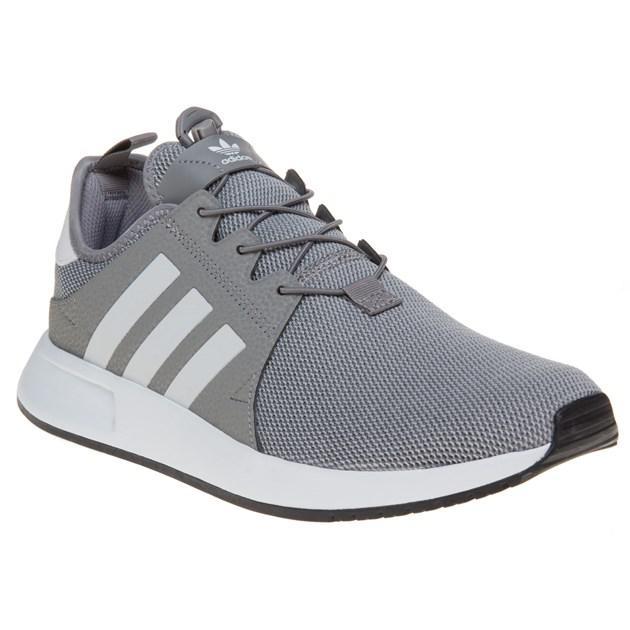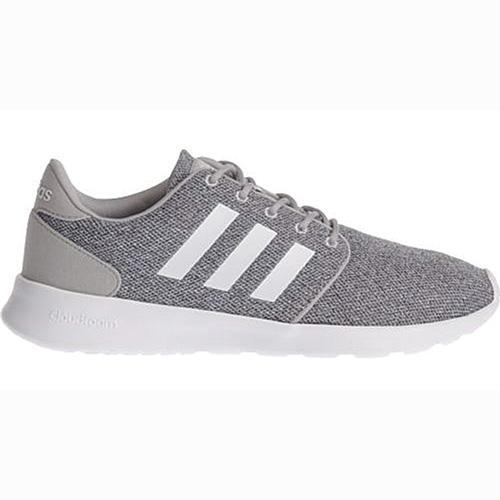The first image is the image on the left, the second image is the image on the right. Assess this claim about the two images: "One shoe has stripes on the side that are white, and the other one has stripes on the side that are a darker color.". Correct or not? Answer yes or no. No. The first image is the image on the left, the second image is the image on the right. For the images shown, is this caption "Both shoes have three white stripes on the side of them." true? Answer yes or no. Yes. 